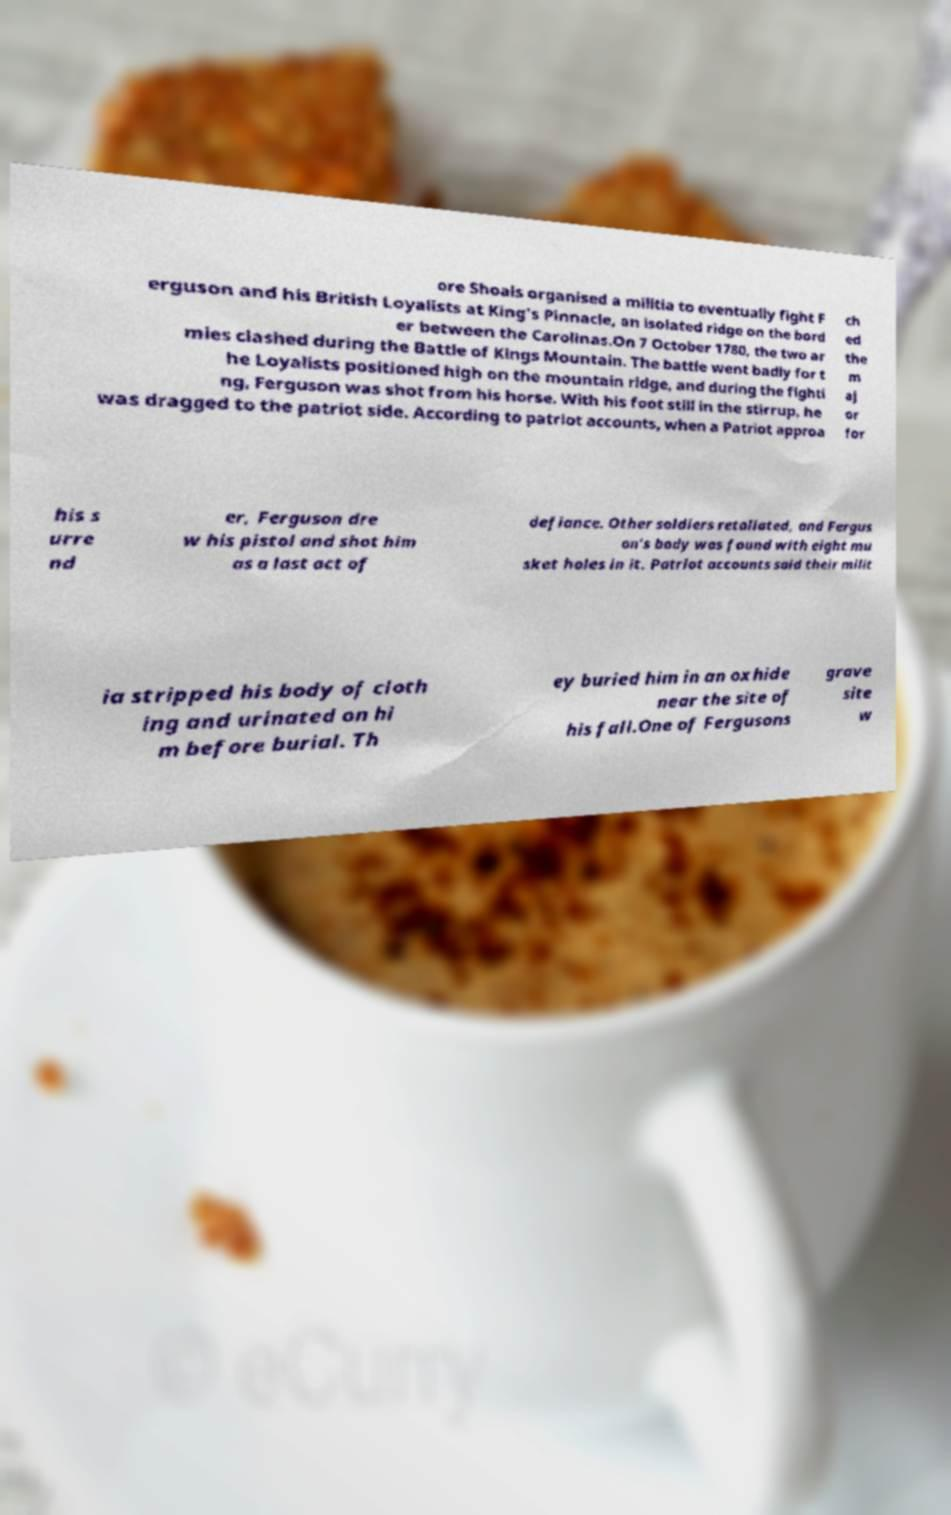Please identify and transcribe the text found in this image. ore Shoals organised a militia to eventually fight F erguson and his British Loyalists at King's Pinnacle, an isolated ridge on the bord er between the Carolinas.On 7 October 1780, the two ar mies clashed during the Battle of Kings Mountain. The battle went badly for t he Loyalists positioned high on the mountain ridge, and during the fighti ng, Ferguson was shot from his horse. With his foot still in the stirrup, he was dragged to the patriot side. According to patriot accounts, when a Patriot approa ch ed the m aj or for his s urre nd er, Ferguson dre w his pistol and shot him as a last act of defiance. Other soldiers retaliated, and Fergus on's body was found with eight mu sket holes in it. Patriot accounts said their milit ia stripped his body of cloth ing and urinated on hi m before burial. Th ey buried him in an oxhide near the site of his fall.One of Fergusons grave site w 